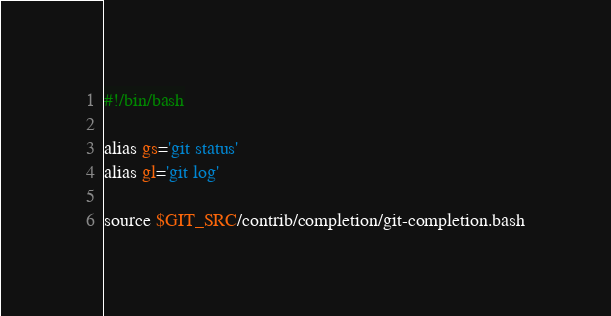Convert code to text. <code><loc_0><loc_0><loc_500><loc_500><_Bash_>#!/bin/bash

alias gs='git status'
alias gl='git log'

source $GIT_SRC/contrib/completion/git-completion.bash
</code> 